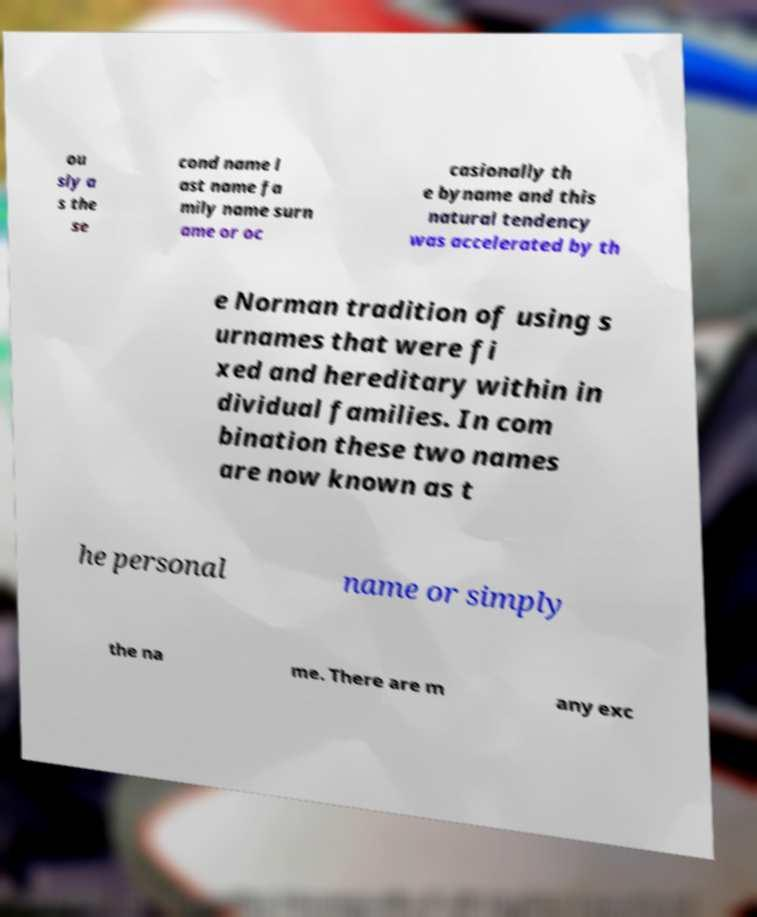Please read and relay the text visible in this image. What does it say? ou sly a s the se cond name l ast name fa mily name surn ame or oc casionally th e byname and this natural tendency was accelerated by th e Norman tradition of using s urnames that were fi xed and hereditary within in dividual families. In com bination these two names are now known as t he personal name or simply the na me. There are m any exc 